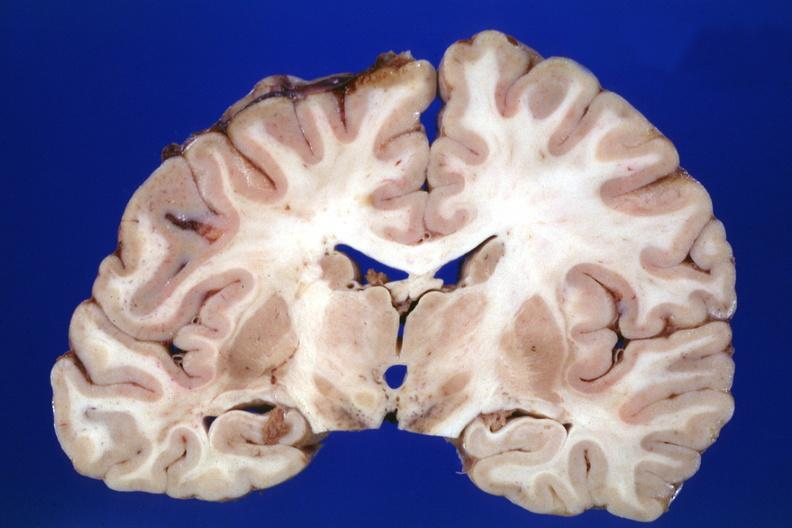what does coronal section cerebral hemispheres case of diabetic cardiomyopathy with history of left hemisphere stroke slides show?
Answer the question using a single word or phrase. No lesion the lesion was in the pons 